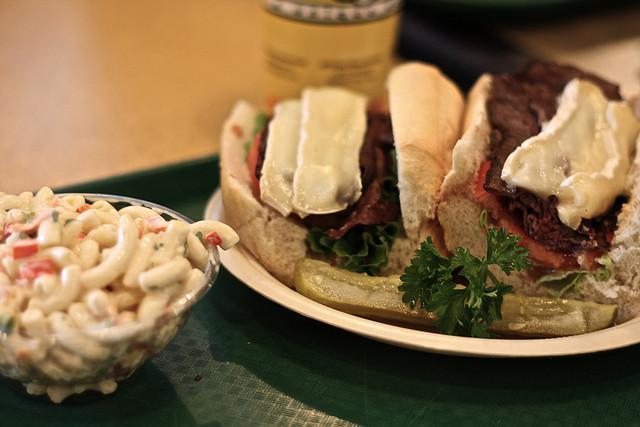How many sandwiches are in the photo?
Give a very brief answer. 2. How many bowls can you see?
Give a very brief answer. 2. How many people aren't holding their phone?
Give a very brief answer. 0. 